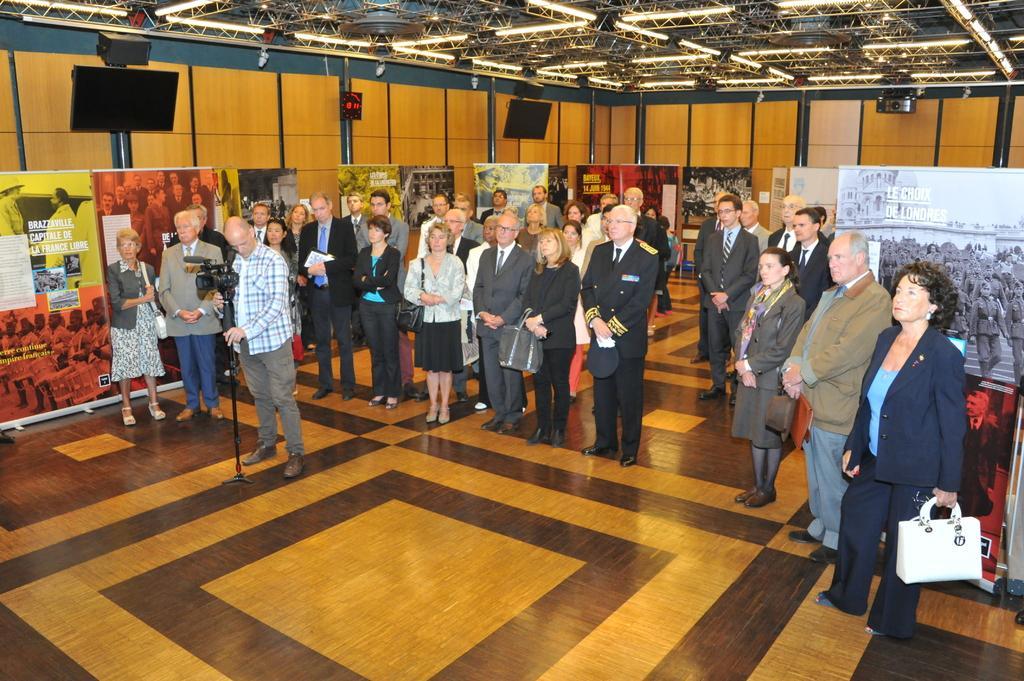Please provide a concise description of this image. In this picture there is a man standing near the camera. We can observe some people standing behind him. There were men and women in this group. There are some posters and photographs in this room. We can observe two televisions here. In the background there is a wall which is in brown color. 